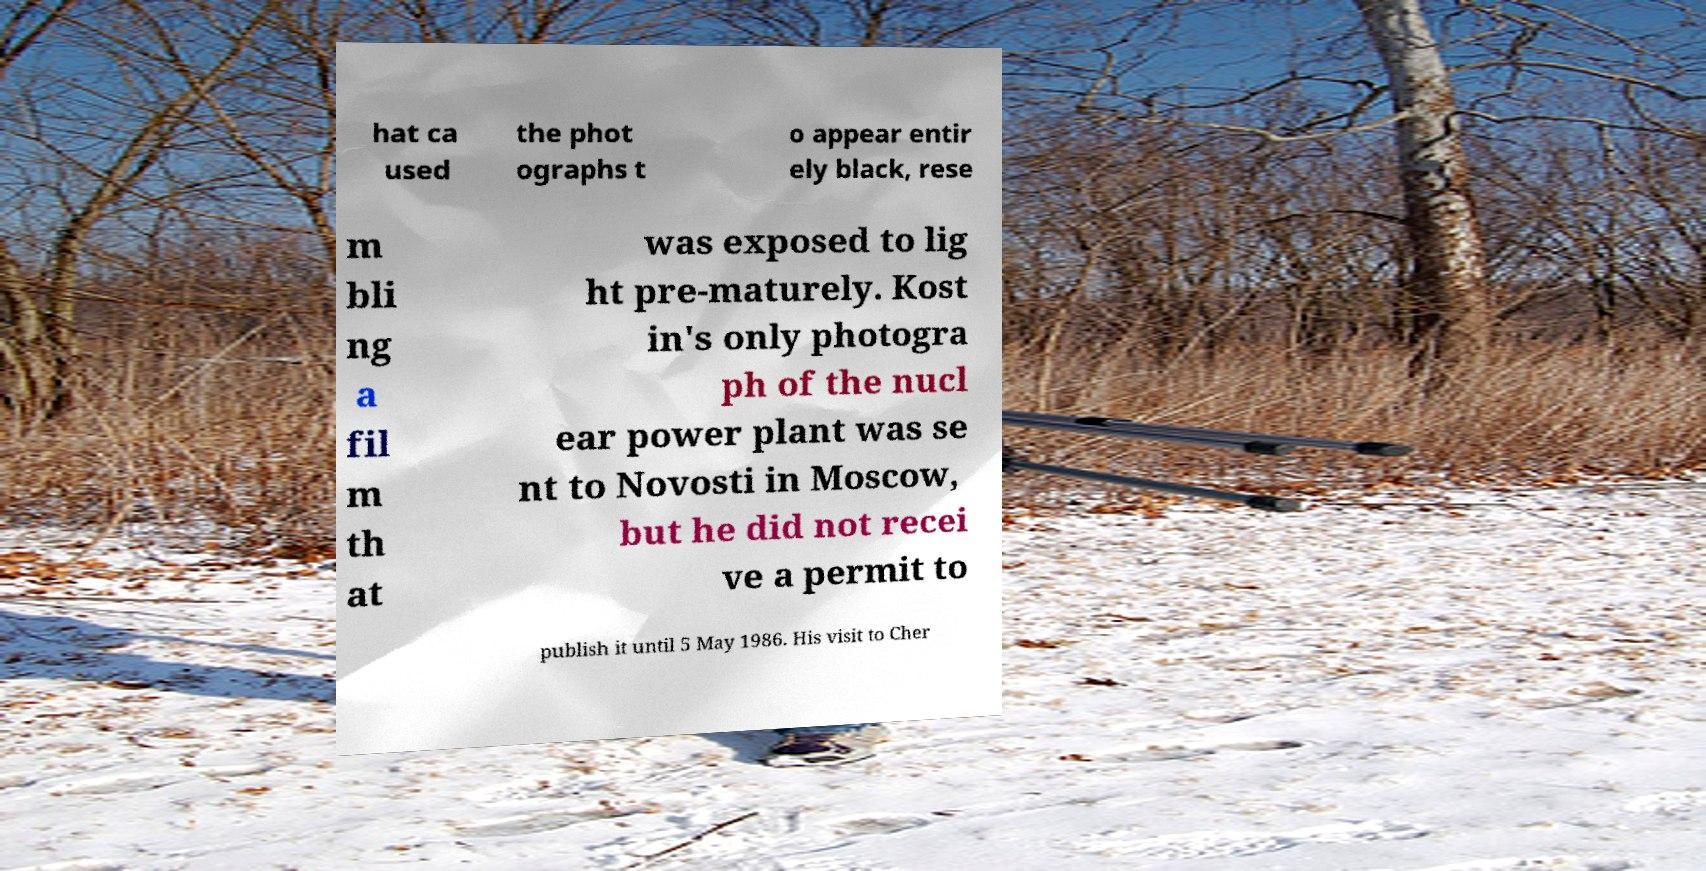Could you extract and type out the text from this image? hat ca used the phot ographs t o appear entir ely black, rese m bli ng a fil m th at was exposed to lig ht pre-maturely. Kost in's only photogra ph of the nucl ear power plant was se nt to Novosti in Moscow, but he did not recei ve a permit to publish it until 5 May 1986. His visit to Cher 